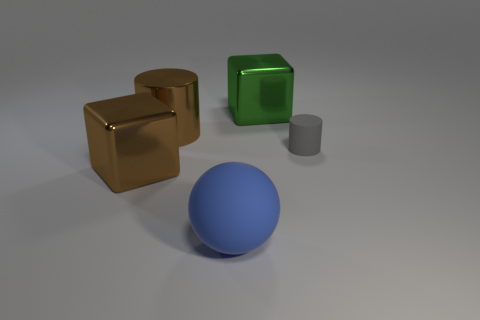The big brown object in front of the brown thing that is behind the big metal cube that is in front of the green metallic object is what shape?
Your response must be concise. Cube. There is another object that is the same shape as the big green metal thing; what color is it?
Your response must be concise. Brown. There is a shiny block that is to the right of the metal object that is in front of the gray rubber object; what color is it?
Your answer should be compact. Green. What size is the brown metal object that is the same shape as the green object?
Make the answer very short. Large. How many brown cubes are made of the same material as the gray object?
Provide a succinct answer. 0. There is a block on the left side of the big green metal thing; how many metallic cubes are to the right of it?
Provide a short and direct response. 1. Are there any large green shiny objects in front of the brown shiny cylinder?
Make the answer very short. No. There is a large brown thing behind the small gray rubber cylinder; is its shape the same as the green metal thing?
Your answer should be compact. No. What material is the cube that is the same color as the big cylinder?
Offer a terse response. Metal. What number of other tiny cylinders are the same color as the matte cylinder?
Offer a very short reply. 0. 